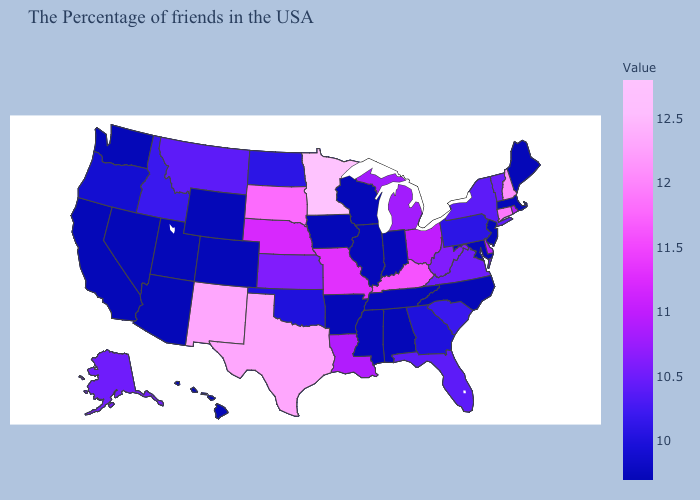Does New York have a lower value than North Carolina?
Write a very short answer. No. Among the states that border Arkansas , does Mississippi have the highest value?
Answer briefly. No. Does California have the highest value in the West?
Short answer required. No. Does Utah have the lowest value in the USA?
Give a very brief answer. Yes. Among the states that border Mississippi , which have the lowest value?
Write a very short answer. Alabama, Tennessee, Arkansas. Does West Virginia have a lower value than Ohio?
Quick response, please. Yes. 